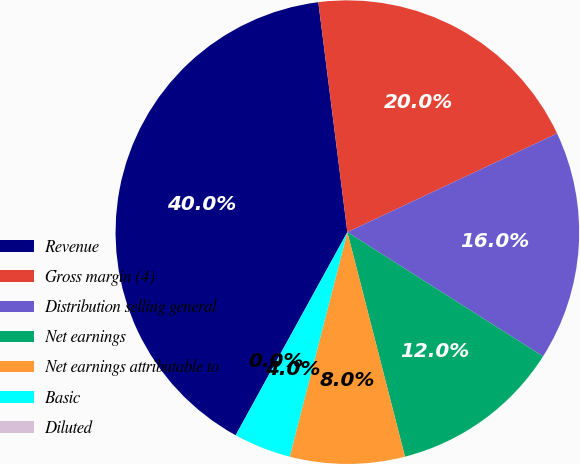<chart> <loc_0><loc_0><loc_500><loc_500><pie_chart><fcel>Revenue<fcel>Gross margin (4)<fcel>Distribution selling general<fcel>Net earnings<fcel>Net earnings attributable to<fcel>Basic<fcel>Diluted<nl><fcel>40.0%<fcel>20.0%<fcel>16.0%<fcel>12.0%<fcel>8.0%<fcel>4.0%<fcel>0.0%<nl></chart> 